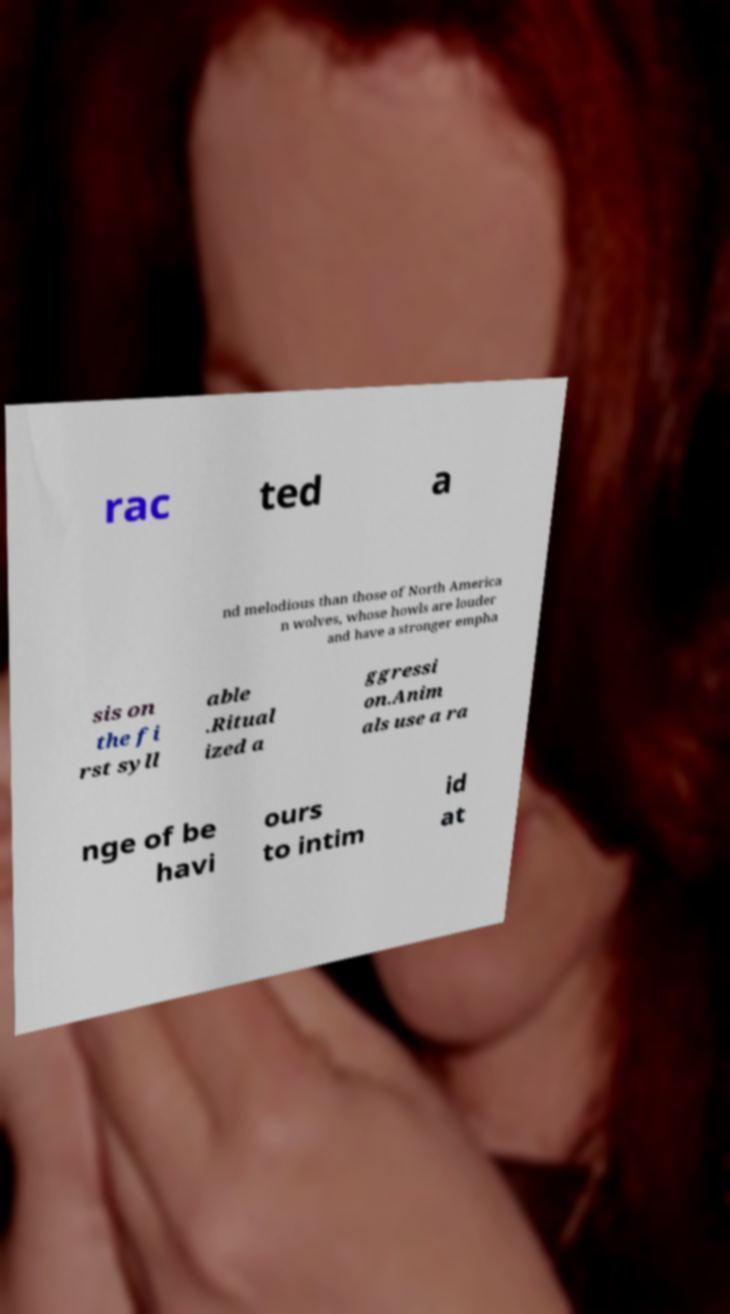Please read and relay the text visible in this image. What does it say? rac ted a nd melodious than those of North America n wolves, whose howls are louder and have a stronger empha sis on the fi rst syll able .Ritual ized a ggressi on.Anim als use a ra nge of be havi ours to intim id at 